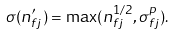<formula> <loc_0><loc_0><loc_500><loc_500>\sigma ( n ^ { \prime } _ { f j } ) = \max ( n ^ { 1 / 2 } _ { f j } , \sigma ^ { p } _ { f j } ) .</formula> 